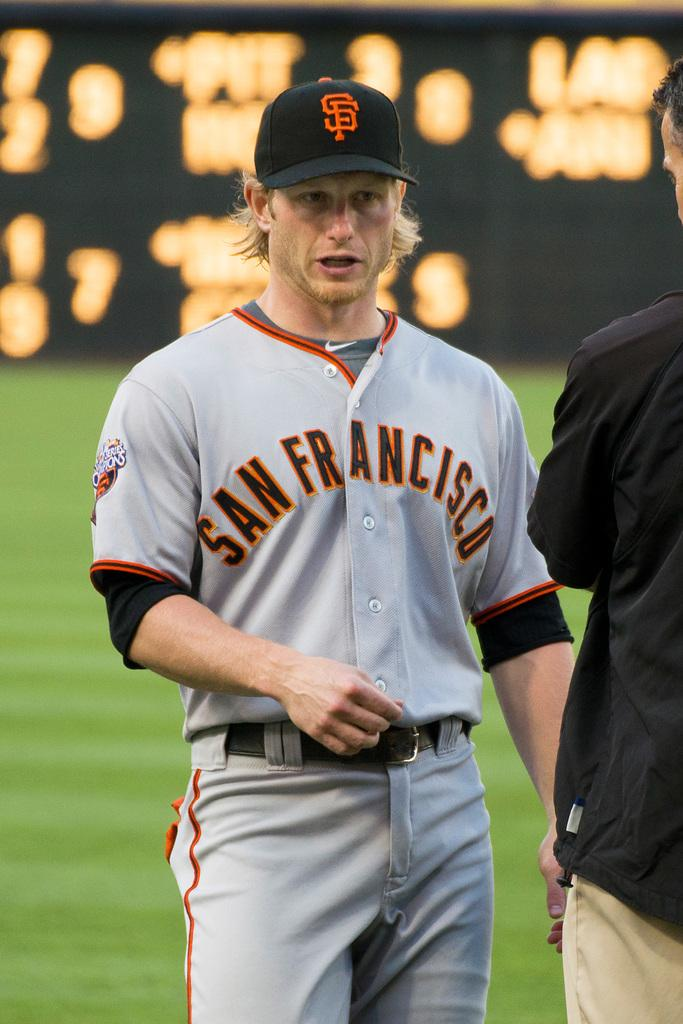<image>
Render a clear and concise summary of the photo. A baseball player from San Francisco looks like he is in shock. 